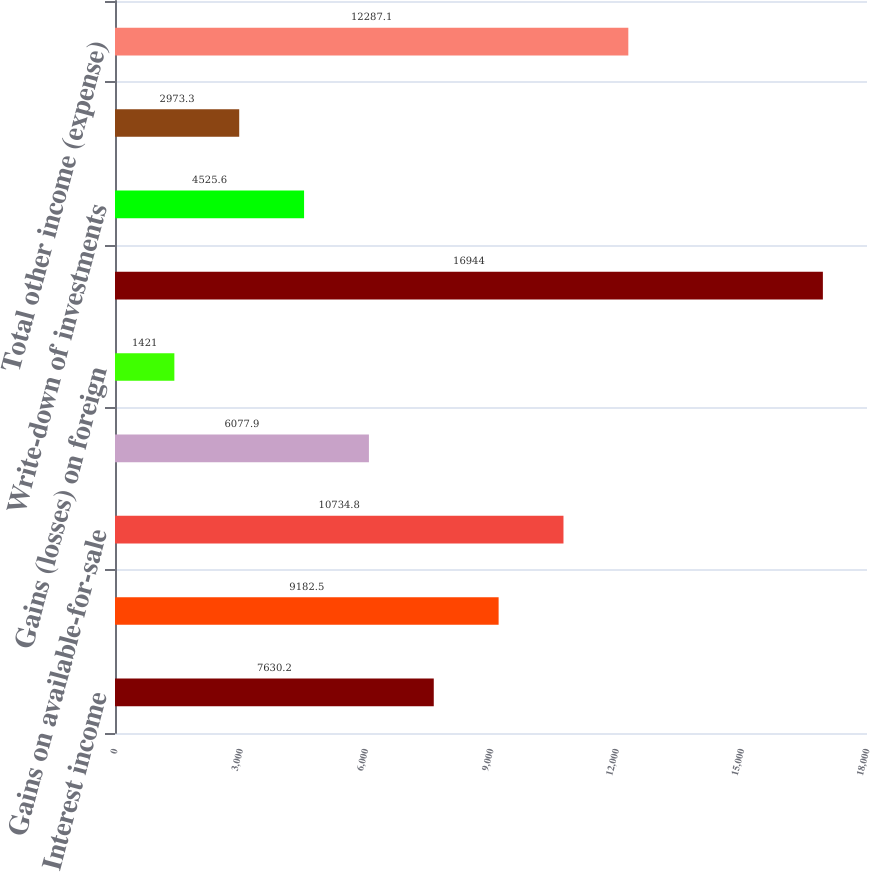Convert chart. <chart><loc_0><loc_0><loc_500><loc_500><bar_chart><fcel>Interest income<fcel>Gains on sale of<fcel>Gains on available-for-sale<fcel>Gains (losses) on trading<fcel>Gains (losses) on foreign<fcel>Equity loss from investments<fcel>Write-down of investments<fcel>Other income (expense)<fcel>Total other income (expense)<nl><fcel>7630.2<fcel>9182.5<fcel>10734.8<fcel>6077.9<fcel>1421<fcel>16944<fcel>4525.6<fcel>2973.3<fcel>12287.1<nl></chart> 